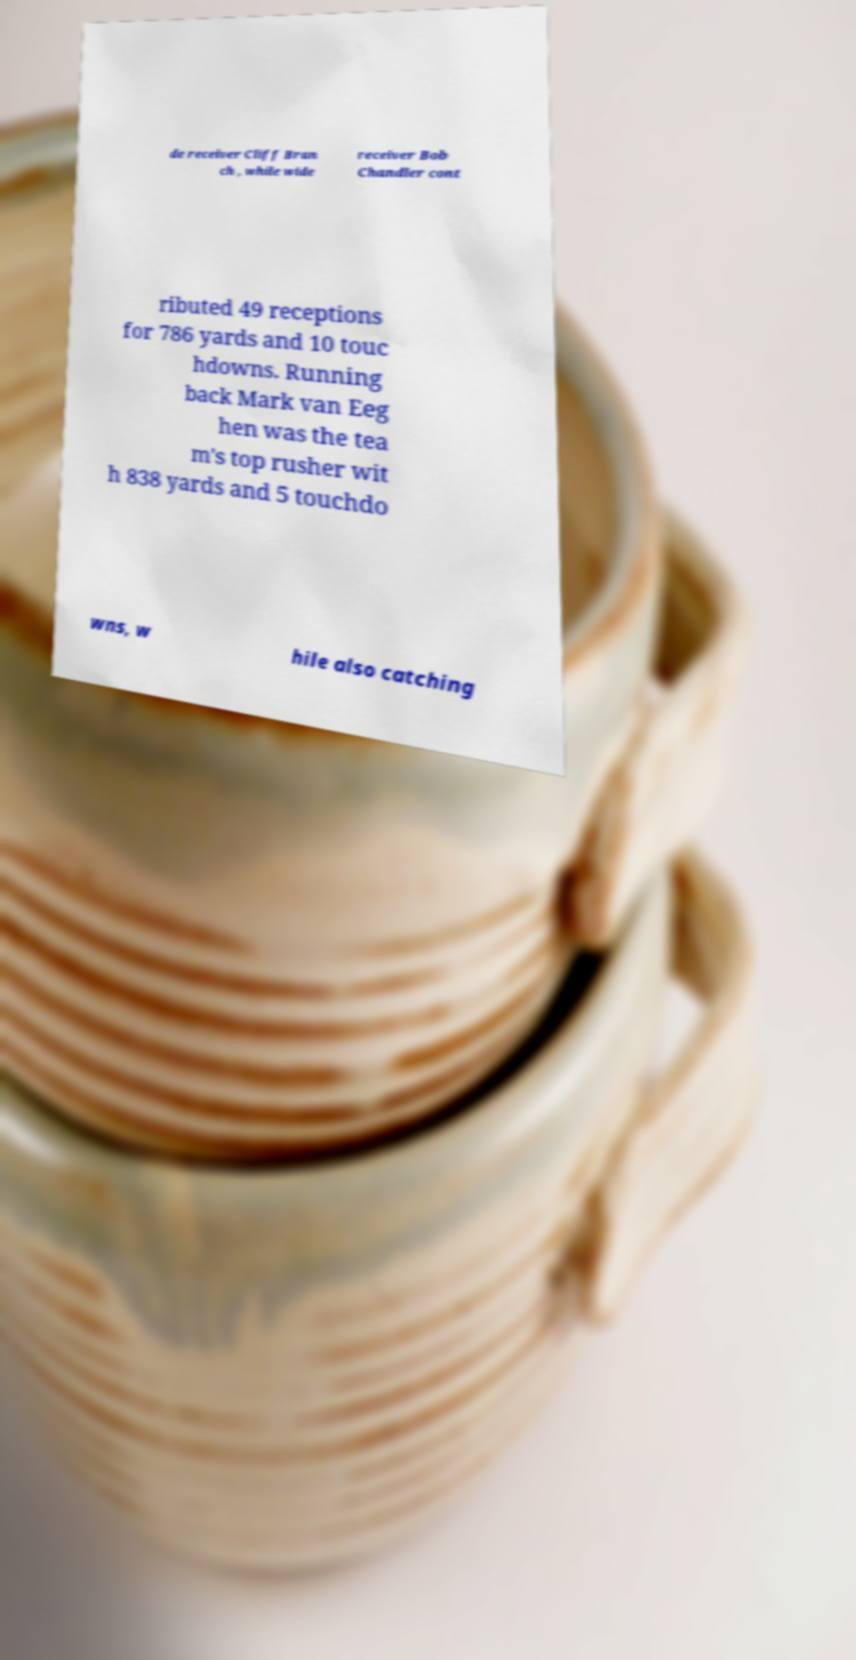There's text embedded in this image that I need extracted. Can you transcribe it verbatim? de receiver Cliff Bran ch , while wide receiver Bob Chandler cont ributed 49 receptions for 786 yards and 10 touc hdowns. Running back Mark van Eeg hen was the tea m's top rusher wit h 838 yards and 5 touchdo wns, w hile also catching 